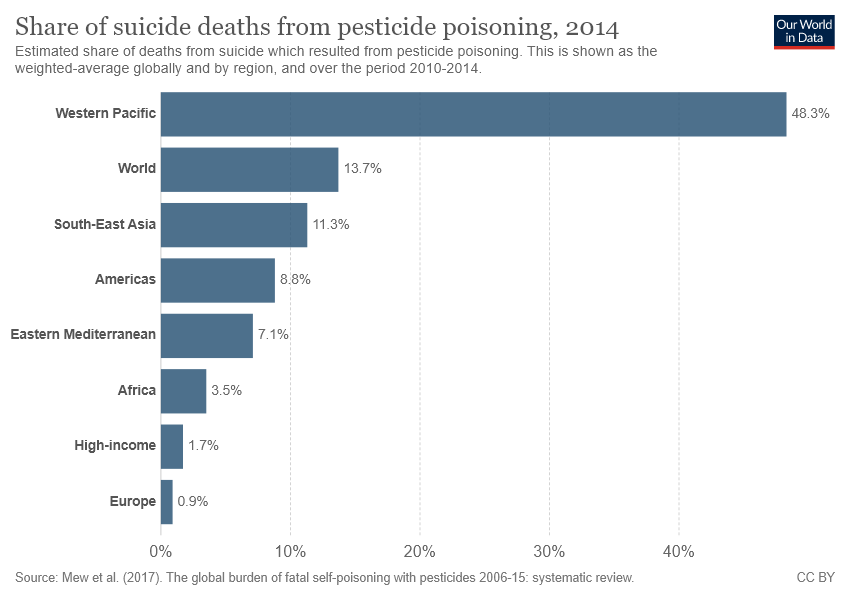Highlight a few significant elements in this photo. The country represented by the smallest bar is Europe. The average value of Europe, Africa, and the Americas is 4.4. 